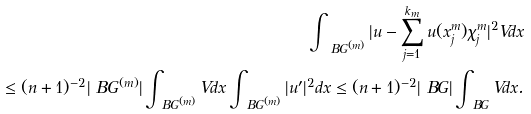<formula> <loc_0><loc_0><loc_500><loc_500>\int _ { \ B G ^ { ( m ) } } | u - \sum _ { j = 1 } ^ { k _ { m } } u ( x ^ { m } _ { j } ) \chi ^ { m } _ { j } | ^ { 2 } V d x \\ \leq ( n + 1 ) ^ { - 2 } | \ B G ^ { ( m ) } | \int _ { \ B G ^ { ( m ) } } V d x \int _ { \ B G ^ { ( m ) } } | u ^ { \prime } | ^ { 2 } d x \leq ( n + 1 ) ^ { - 2 } | \ B G | \int _ { \ B G } V d x .</formula> 